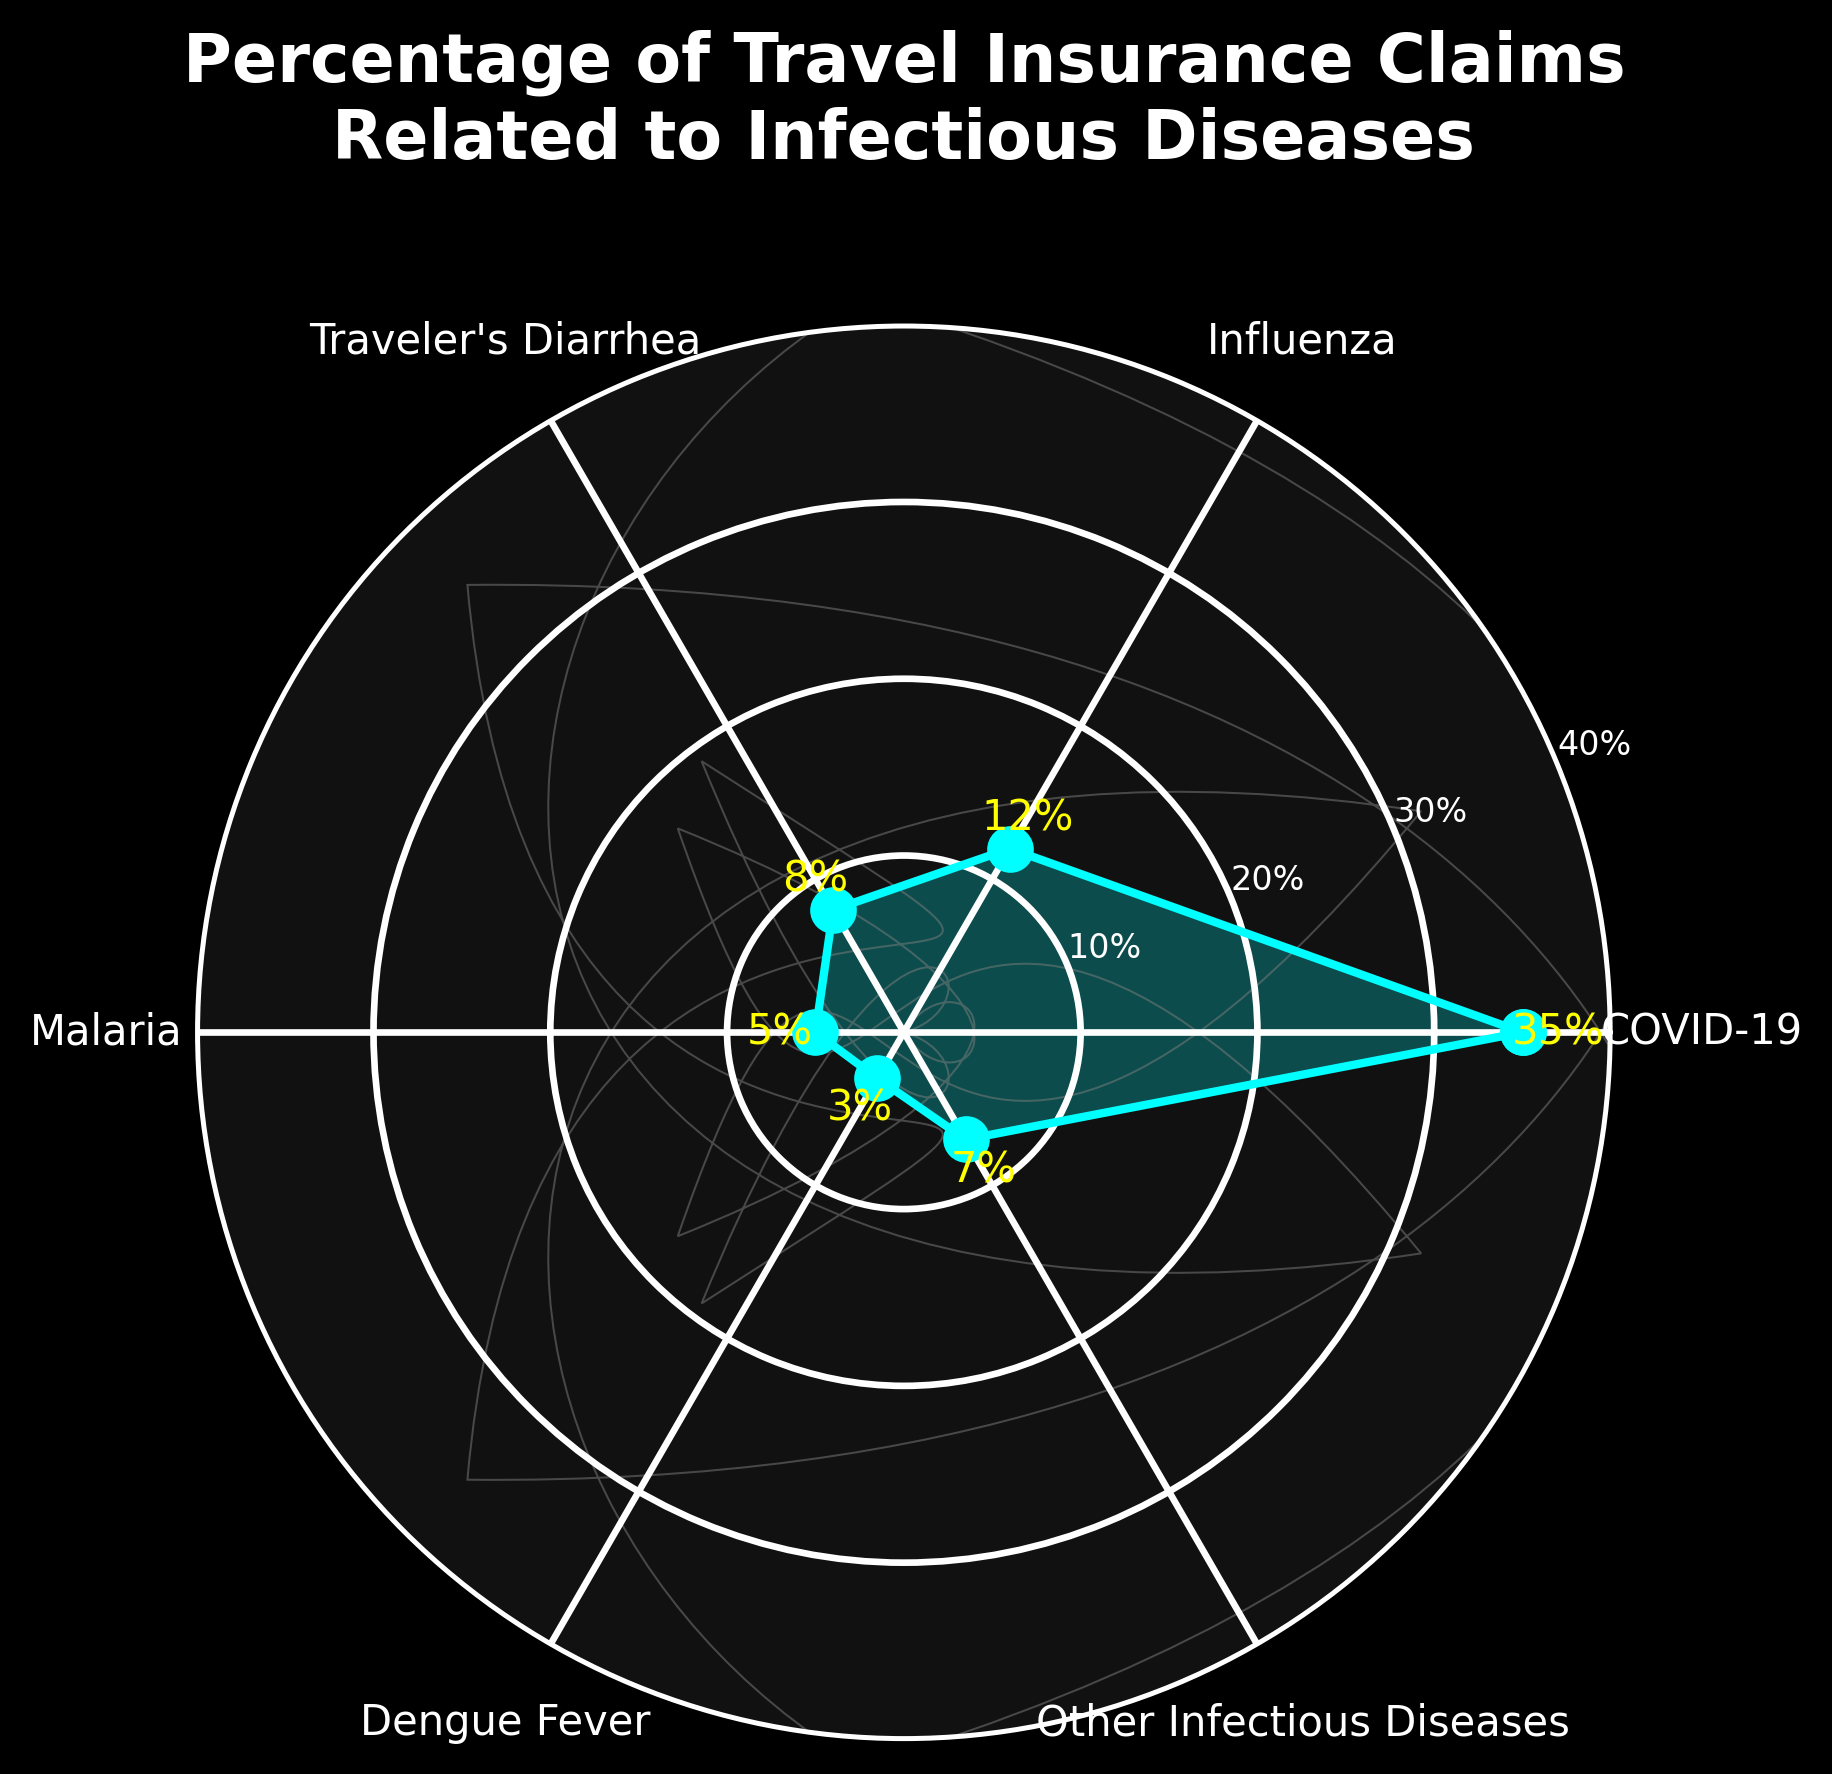What is the title of the figure? The title is usually located at the top of the figure and summarizes the content visualized. The title here is clear and concise, easily found in the figure.
Answer: Percentage of Travel Insurance Claims Related to Infectious Diseases How many categories are shown in the figure? Count the unique labels around the circular plot indicating different diseases. Each label represents a category.
Answer: 6 Which category has the highest percentage of travel insurance claims related to infectious diseases? Look for the category with the highest value indicated by the points and lines on the circular plot. The text annotations and the position of the markers help identify this easily.
Answer: COVID-19 What is the percentage value for Influenza? Find the label for Influenza and check the text annotation next to it, which shows the percentage value for this category.
Answer: 12% How many categories have a percentage value lower than 10%? Look at the text annotations for each category and count how many have values less than 10. You need to check each category and compare it to 10.
Answer: 4 Which infectious disease’s percentage is closest to 40% on the figure? Look at the text annotations and check which category has a value nearest to 40%. Then identify the corresponding disease label.
Answer: COVID-19 What is the average percentage of the listed infectious diseases? Sum the percentage values for all categories and divide by the number of categories to find the average. (35 + 12 + 8 + 5 + 3 + 7) / 6 = 70 / 6 ≈ 11.67%
Answer: 11.67% If you combine the percentages of COVID-19 and Influenza, what portion of the total does this represent? Add the percentage values for COVID-19 and Influenza, then divide by the total of all percentages to find the portion. (35 + 12) = 47, Total = 35 + 12 + 8 + 5 + 3 + 7 = 70, Portion = 47/70 ≈ 0.6714
Answer: Approximately 67.14% 